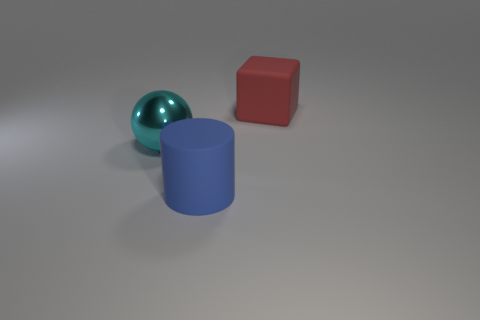Add 1 tiny green rubber objects. How many objects exist? 4 Subtract all cubes. How many objects are left? 2 Add 2 large objects. How many large objects are left? 5 Add 3 spheres. How many spheres exist? 4 Subtract 0 brown cylinders. How many objects are left? 3 Subtract all yellow metallic balls. Subtract all big shiny objects. How many objects are left? 2 